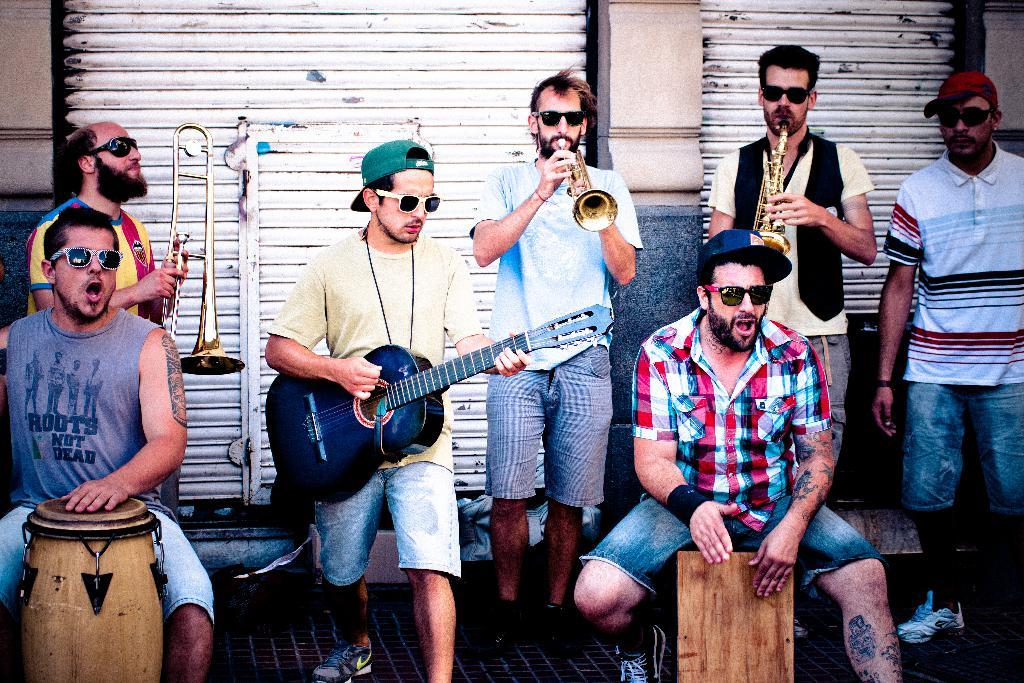How many people are in the image? There are persons in the image. What are the persons doing in the image? The persons are playing musical instruments. What type of wax can be seen melting on the head of one of the persons in the image? There is no wax or melting visible in the image; the persons are playing musical instruments. What is the relation between the persons in the image? The provided facts do not give any information about the relationship between the persons in the image. 